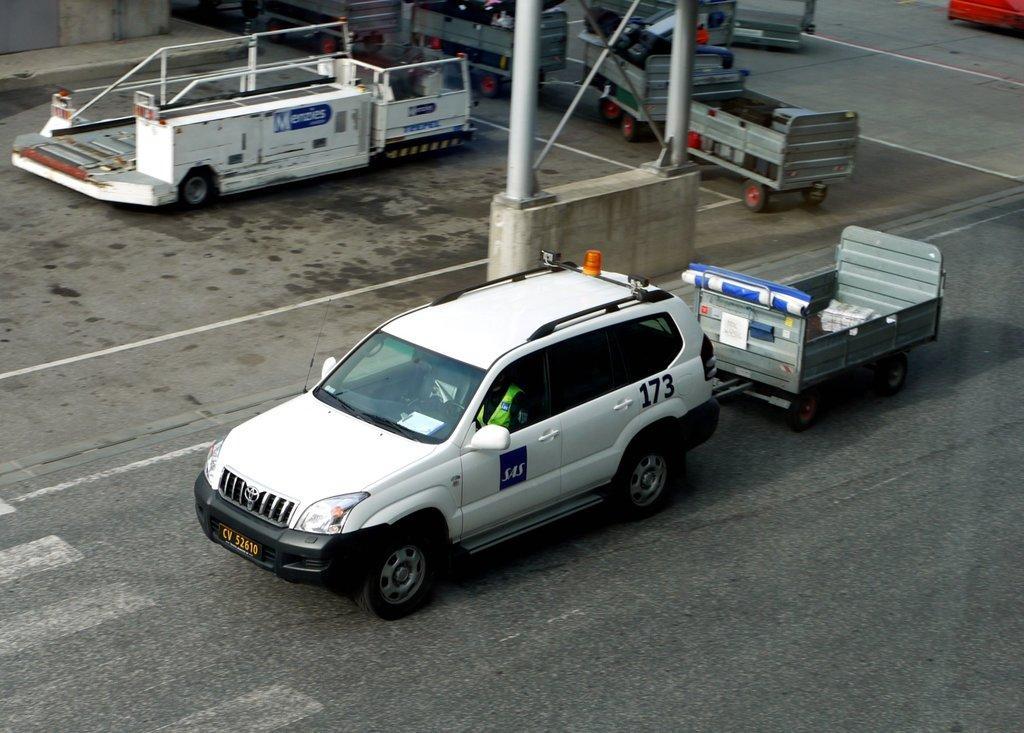In one or two sentences, can you explain what this image depicts? In this picture there is a vehicle on the road and there is a trolley on the road. At the back there are trolleys and there is a vehicle and there are poles on the wall. At the bottom there is a road. 